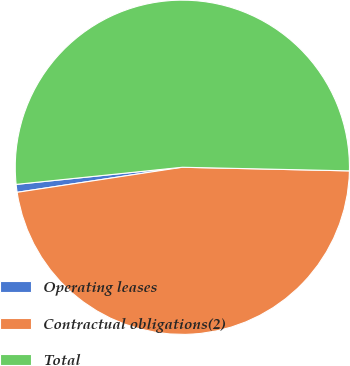Convert chart to OTSL. <chart><loc_0><loc_0><loc_500><loc_500><pie_chart><fcel>Operating leases<fcel>Contractual obligations(2)<fcel>Total<nl><fcel>0.76%<fcel>47.26%<fcel>51.98%<nl></chart> 